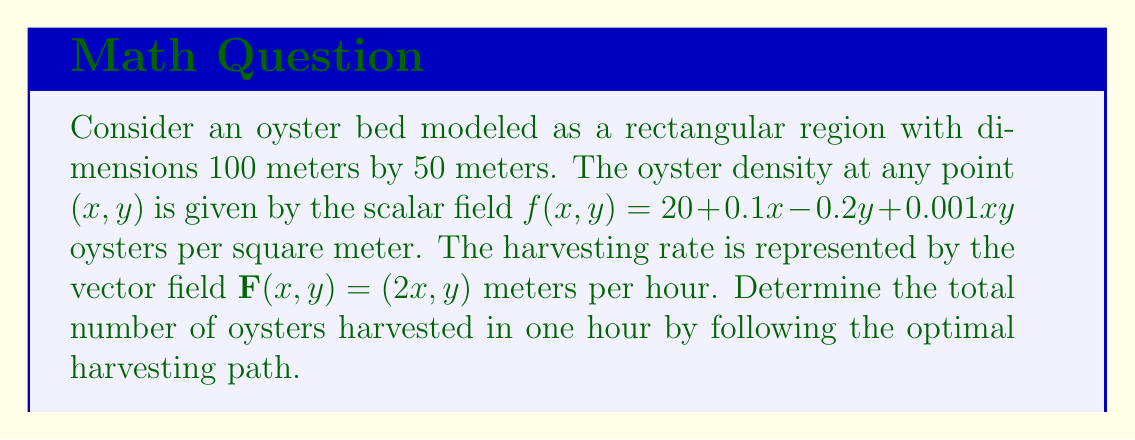Teach me how to tackle this problem. To solve this problem, we'll follow these steps:

1) The optimal harvesting path is the one that maximizes the line integral of the oyster density along the vector field. This is given by the line integral:

   $\oint_C f(x,y) \mathbf{F} \cdot d\mathbf{r}$

2) We need to use Green's theorem to convert this line integral to a double integral over the region:

   $\oint_C f(x,y) \mathbf{F} \cdot d\mathbf{r} = \iint_R \left(\frac{\partial (fF_y)}{\partial x} - \frac{\partial (fF_x)}{\partial y}\right) dA$

3) Let's calculate the integrand:

   $\frac{\partial (fF_y)}{\partial x} = \frac{\partial}{\partial x}[(20 + 0.1x - 0.2y + 0.001xy)y] = 0.1y + 0.001y^2$

   $\frac{\partial (fF_x)}{\partial y} = \frac{\partial}{\partial y}[(20 + 0.1x - 0.2y + 0.001xy)(2x)] = -0.4x + 0.002x^2$

4) The integrand becomes:

   $(0.1y + 0.001y^2) - (-0.4x + 0.002x^2) = 0.4x + 0.1y + 0.001y^2 - 0.002x^2$

5) Now we set up the double integral:

   $\iint_R (0.4x + 0.1y + 0.001y^2 - 0.002x^2) dA$

   where $R$ is the rectangle $[0,100] \times [0,50]$

6) Evaluating this integral:

   $\int_0^{50} \int_0^{100} (0.4x + 0.1y + 0.001y^2 - 0.002x^2) dx dy$

   $= \int_0^{50} [0.4\frac{x^2}{2} + 0.1xy + 0.001y^2x - 0.002\frac{x^3}{3}]_0^{100} dy$

   $= \int_0^{50} (2000 + 10y + 0.1y^2 - 6666.67) dy$

   $= [2000y + 5y^2 + \frac{0.1y^3}{3} - 6666.67y]_0^{50}$

   $= 100000 + 12500 + 4166.67 - 333333.33$

   $= -216666.66$

7) This negative result indicates that we should reverse the direction of the vector field to maximize the harvest. The total number of oysters harvested is the absolute value of this result.
Answer: 216,667 oysters 